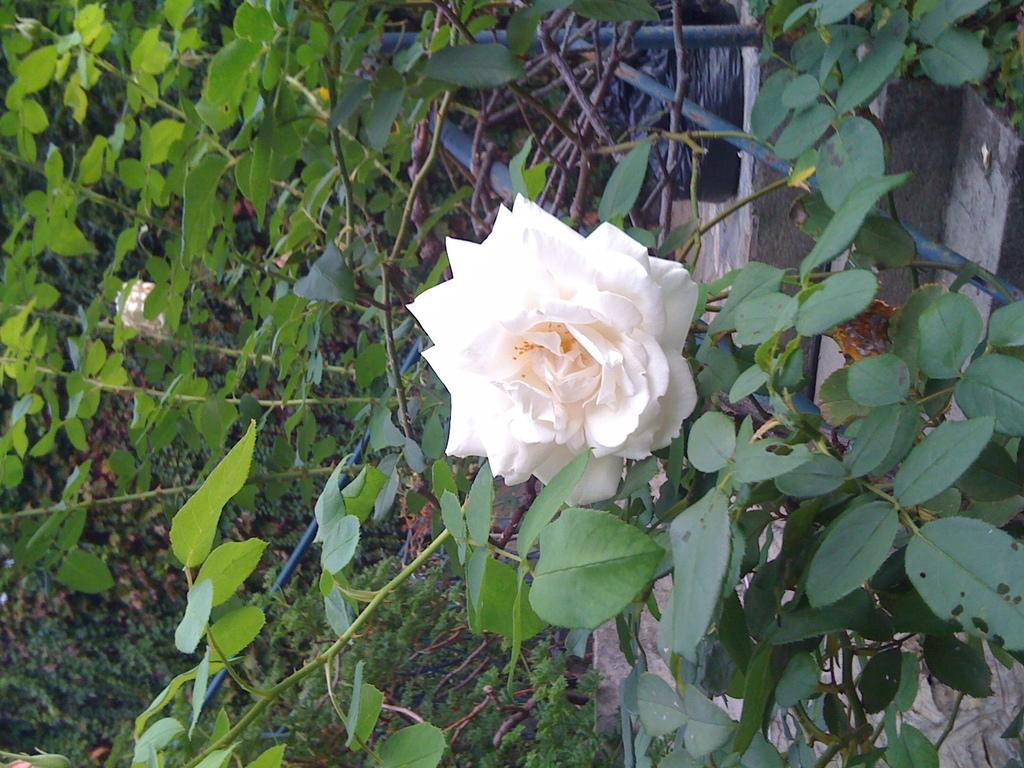What types of living organisms are present in the image? There are many plants in the image. Can you describe a specific type of plant in the image? There is a flower in the image. What color is the flower in the image? The flower is white in color. How does the flower express its feelings of hate in the image? The flower does not express any feelings of hate in the image, as plants do not have emotions. 